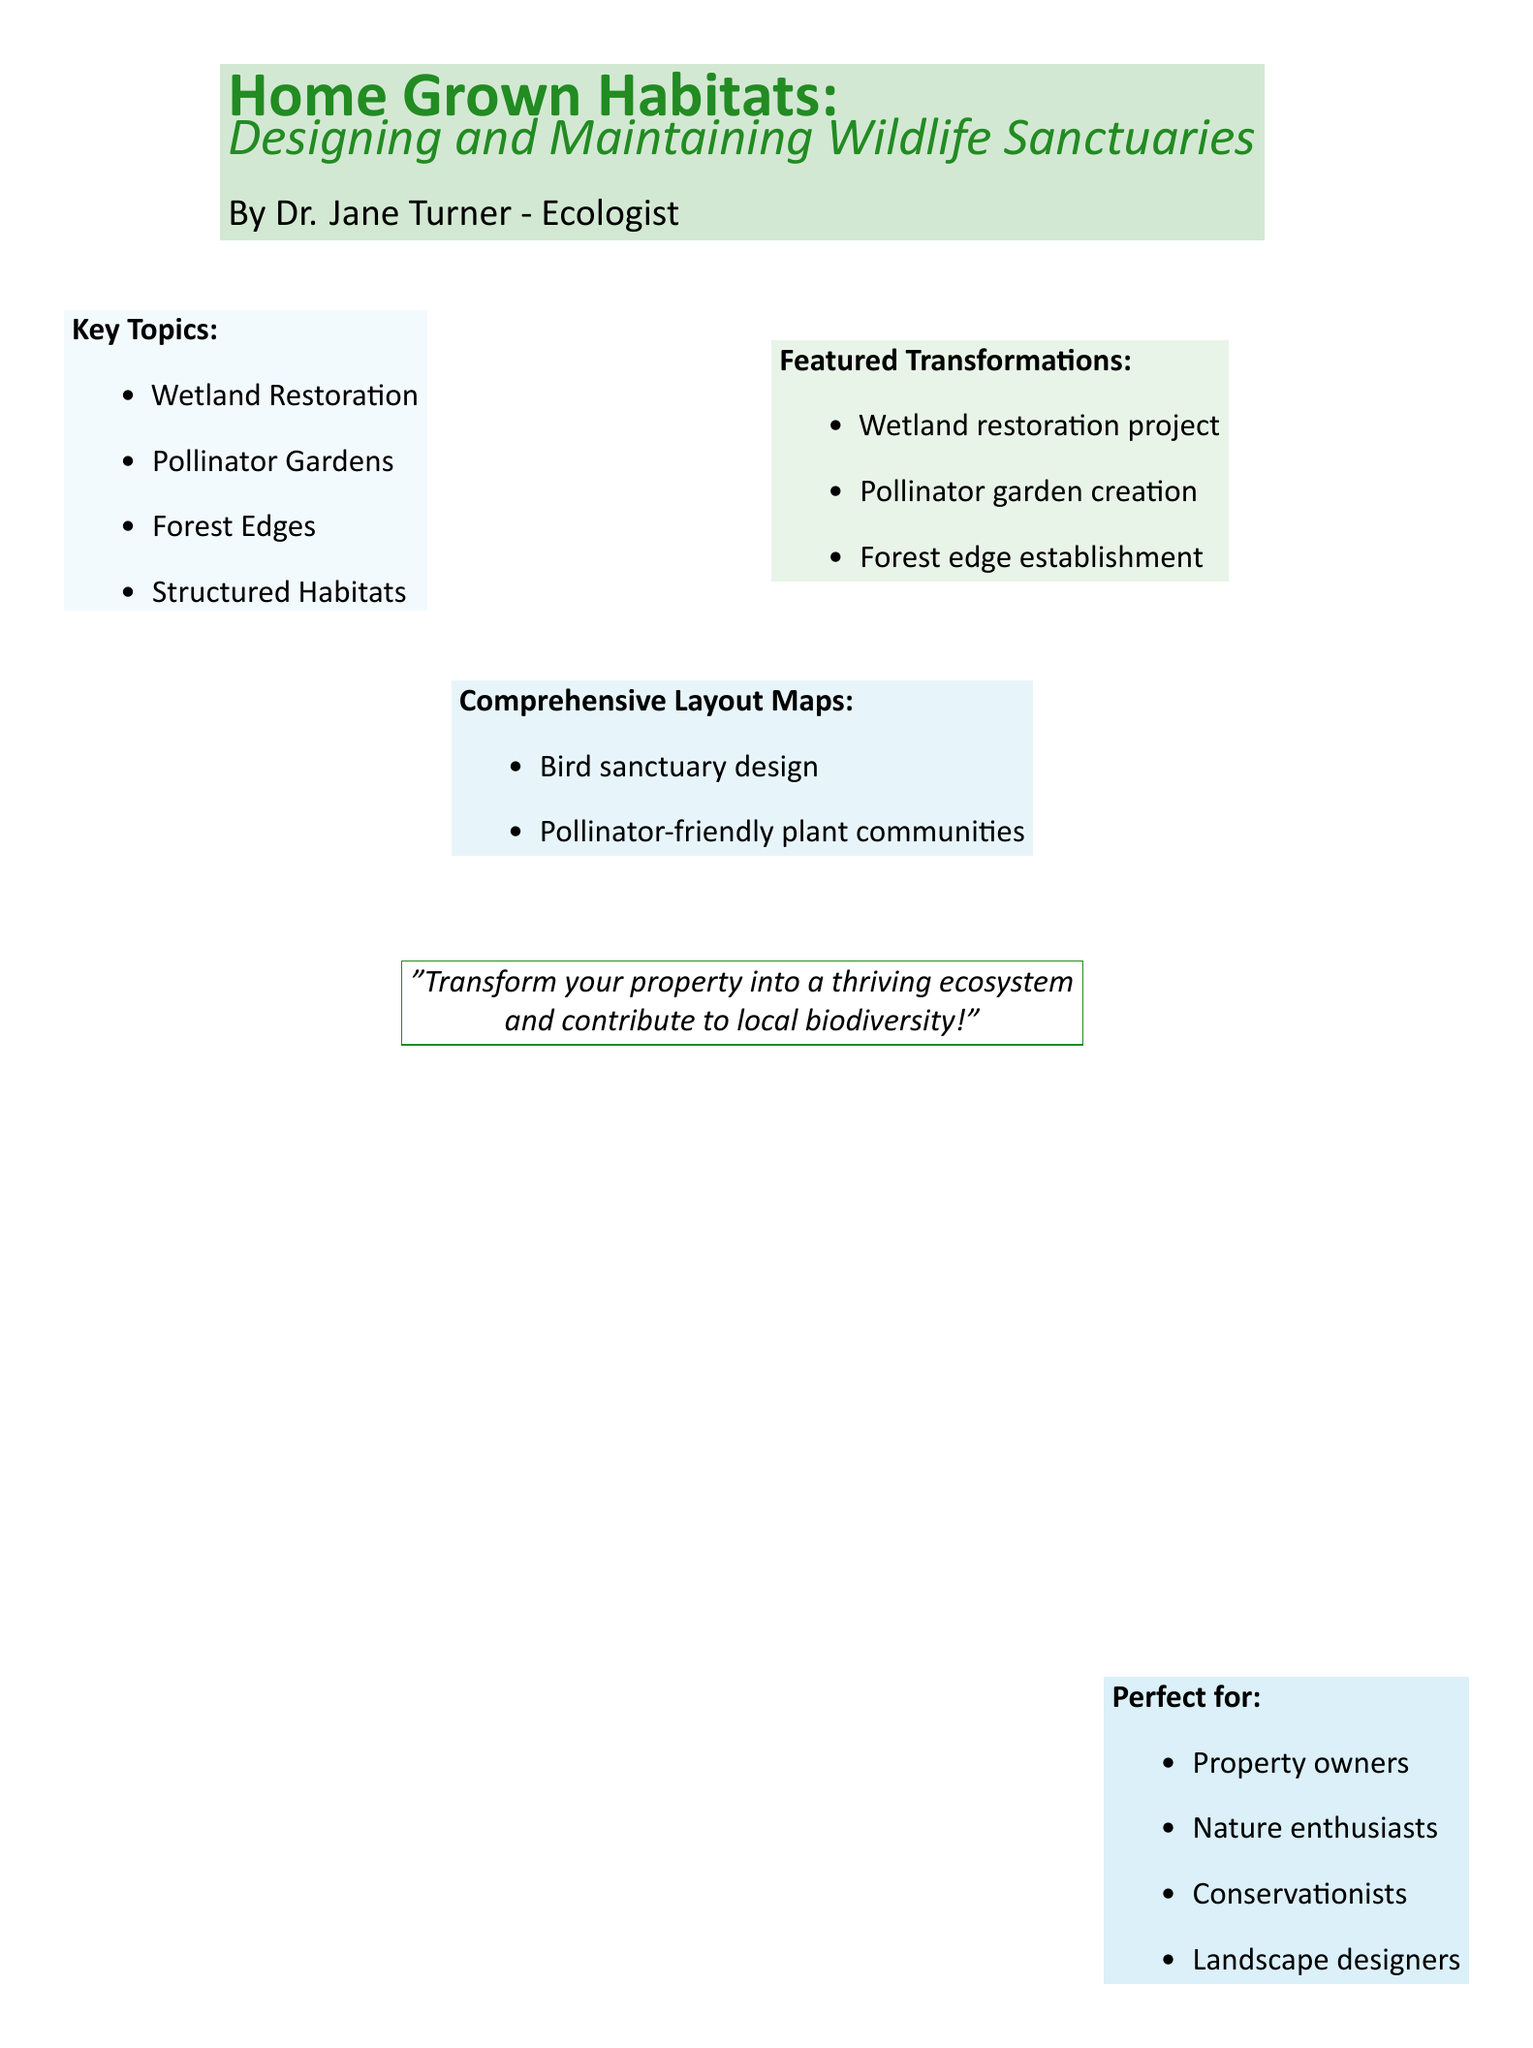What is the title of the book? The title is clearly stated at the top of the document in a prominent font.
Answer: Home Grown Habitats: Designing and Maintaining Wildlife Sanctuaries Who is the author of the book? The author's name is listed below the title, providing the identity of the writer.
Answer: Dr. Jane Turner What is one key topic mentioned in the document? The document lists several key topics relevant to wildlife sanctuaries.
Answer: Wetland Restoration What type of communities are featured in the comprehensive layout maps? The layout maps aim to encourage specific types of plant communities for wildlife.
Answer: Pollinator-friendly plant communities How many featured transformations are listed in the document? The document enumerates several transformations that can be achieved in a wildlife sanctuary.
Answer: Three Who is the book perfect for? The section at the bottom of the document indicates groups of people ideal for this book.
Answer: Property owners What color is used for the background of the key topics section? The document specifies the color used for highlighting the key topics.
Answer: Sky blue What is one of the transformations highlighted in the document? The transformations section lists specific improvements to be made in habitats.
Answer: Pollinator garden creation 